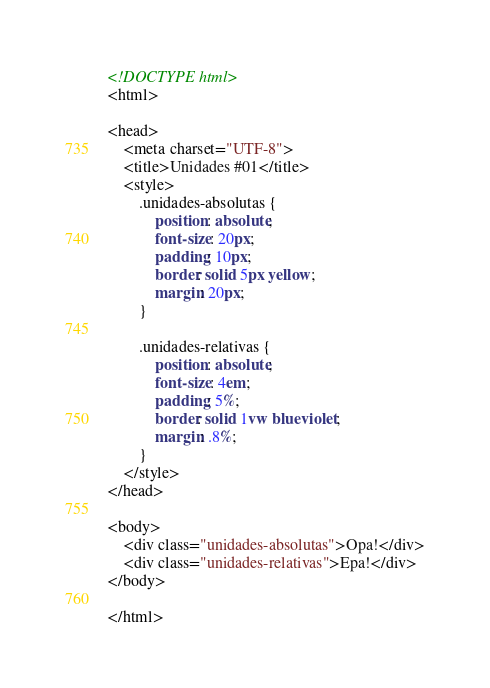Convert code to text. <code><loc_0><loc_0><loc_500><loc_500><_HTML_><!DOCTYPE html>
<html>

<head>
    <meta charset="UTF-8">
    <title>Unidades #01</title>
    <style>
        .unidades-absolutas {
            position: absolute;
            font-size: 20px;
            padding: 10px;
            border: solid 5px yellow;
            margin: 20px;
        }

        .unidades-relativas {
            position: absolute;
            font-size: 4em;
            padding: 5%;
            border: solid 1vw blueviolet;
            margin: .8%;
        }
    </style>
</head>

<body>
    <div class="unidades-absolutas">Opa!</div>
    <div class="unidades-relativas">Epa!</div>
</body>

</html></code> 